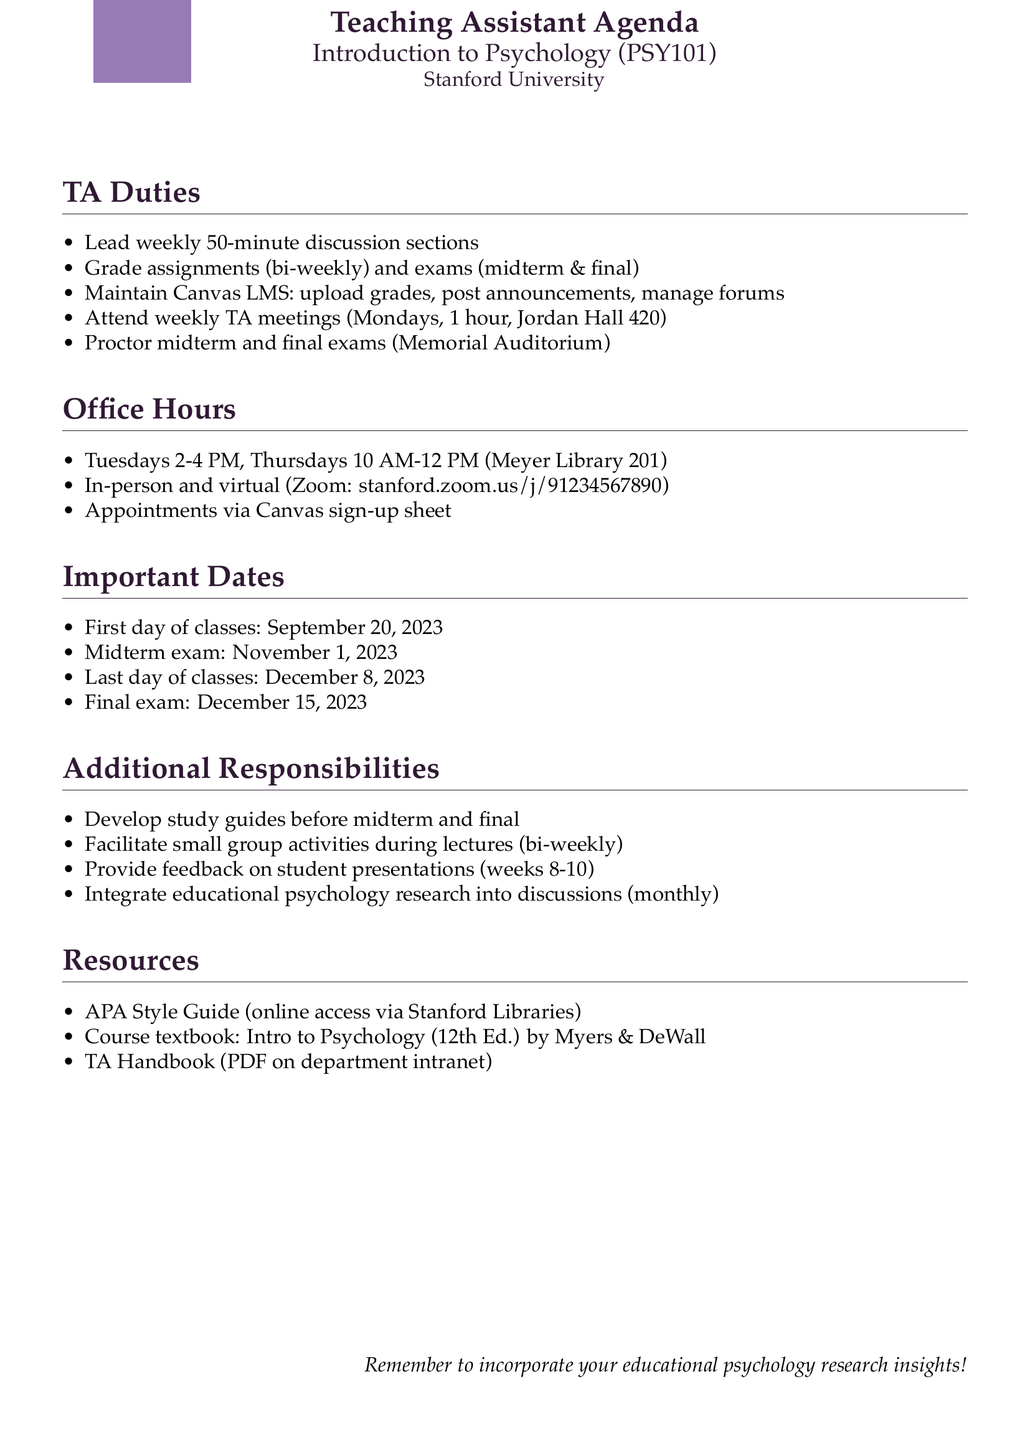What is the course code? The course code is explicitly mentioned in the course details section.
Answer: PSY101 How often do TA meetings occur? The frequency of TA meetings can be found in the duties section that outlines TA responsibilities.
Answer: Every Monday When is the first day of classes? The important dates section lists significant events, including the first day of classes.
Answer: September 20, 2023 How long is each discussion section led by TAs? The duration of the discussion sections is specified in the teaching assistant duties section.
Answer: 50 minutes What are the office hours on Thursdays? The schedule for office hours is detailed in its respective section, providing specific times for each day.
Answer: 10:00 AM - 12:00 PM Where do TAs maintain course records? The location where TAs manage course records is indicated in the teaching assistant duties section.
Answer: Canvas LMS What is the estimated time per week for grading? The estimated time required for grading assignments and exams is given under the duties section.
Answer: 10-15 hours per week How many hours do TAs have for their additional responsibility of providing feedback on student presentations? The frequency of providing feedback is mentioned along with the timeframe in which it occurs.
Answer: During weeks 8-10 of the quarter What platform is used for virtual office hours? The document specifies a link for virtual office hours in the office hours section.
Answer: Zoom 